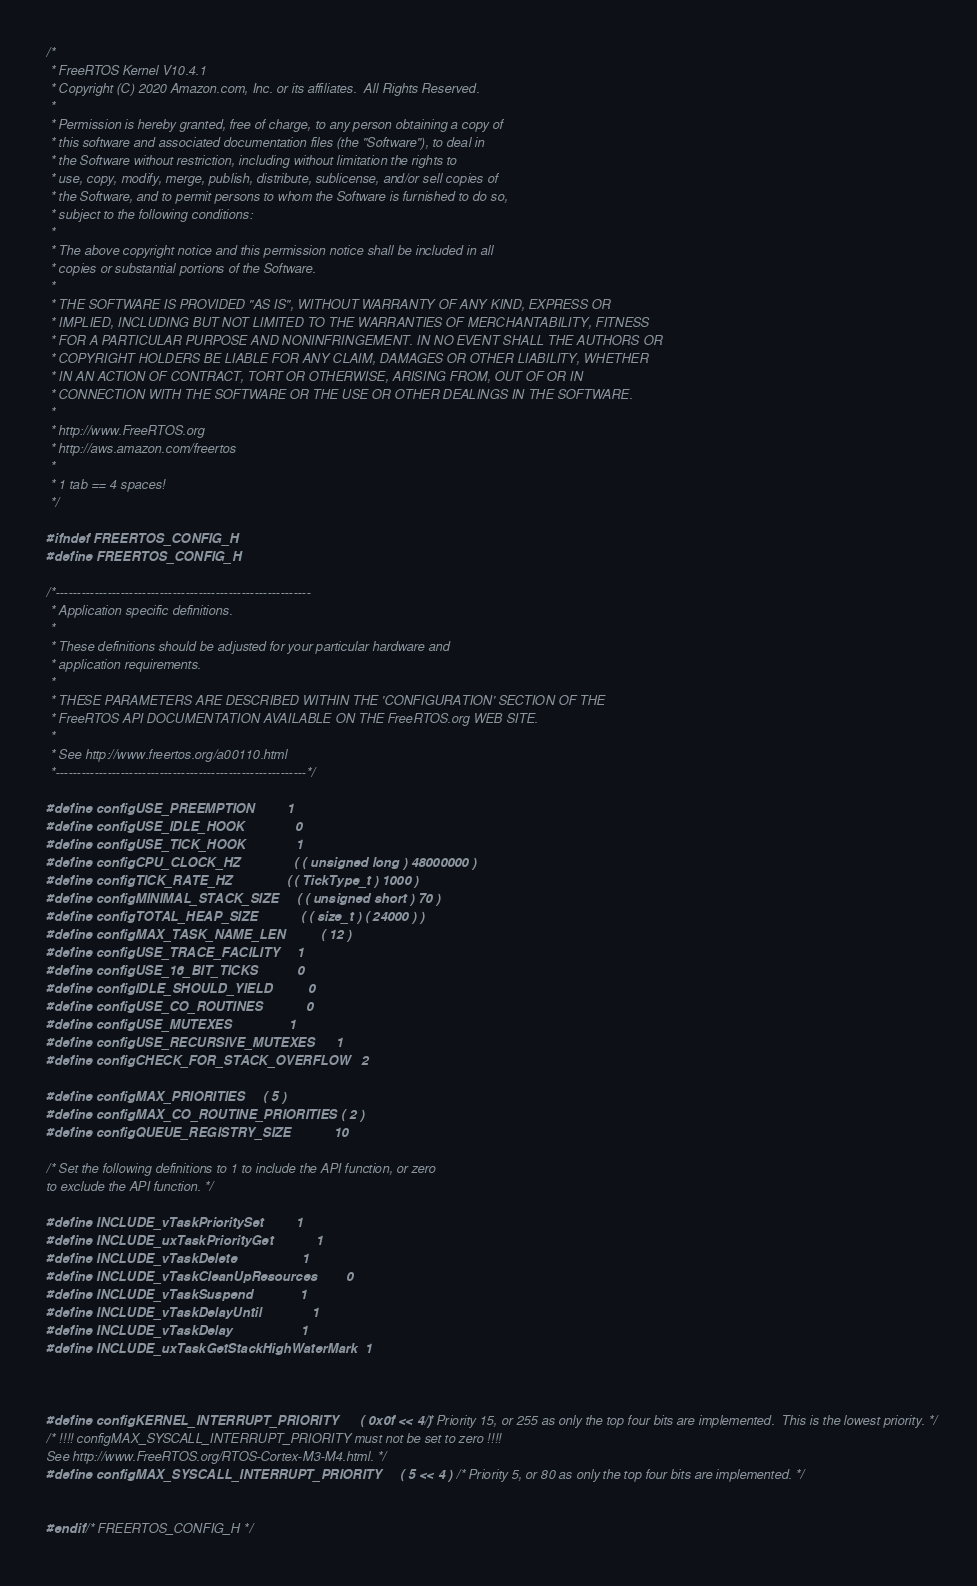<code> <loc_0><loc_0><loc_500><loc_500><_C_>/*
 * FreeRTOS Kernel V10.4.1
 * Copyright (C) 2020 Amazon.com, Inc. or its affiliates.  All Rights Reserved.
 *
 * Permission is hereby granted, free of charge, to any person obtaining a copy of
 * this software and associated documentation files (the "Software"), to deal in
 * the Software without restriction, including without limitation the rights to
 * use, copy, modify, merge, publish, distribute, sublicense, and/or sell copies of
 * the Software, and to permit persons to whom the Software is furnished to do so,
 * subject to the following conditions:
 *
 * The above copyright notice and this permission notice shall be included in all
 * copies or substantial portions of the Software.
 *
 * THE SOFTWARE IS PROVIDED "AS IS", WITHOUT WARRANTY OF ANY KIND, EXPRESS OR
 * IMPLIED, INCLUDING BUT NOT LIMITED TO THE WARRANTIES OF MERCHANTABILITY, FITNESS
 * FOR A PARTICULAR PURPOSE AND NONINFRINGEMENT. IN NO EVENT SHALL THE AUTHORS OR
 * COPYRIGHT HOLDERS BE LIABLE FOR ANY CLAIM, DAMAGES OR OTHER LIABILITY, WHETHER
 * IN AN ACTION OF CONTRACT, TORT OR OTHERWISE, ARISING FROM, OUT OF OR IN
 * CONNECTION WITH THE SOFTWARE OR THE USE OR OTHER DEALINGS IN THE SOFTWARE.
 *
 * http://www.FreeRTOS.org
 * http://aws.amazon.com/freertos
 *
 * 1 tab == 4 spaces!
 */

#ifndef FREERTOS_CONFIG_H
#define FREERTOS_CONFIG_H

/*-----------------------------------------------------------
 * Application specific definitions.
 *
 * These definitions should be adjusted for your particular hardware and
 * application requirements.
 *
 * THESE PARAMETERS ARE DESCRIBED WITHIN THE 'CONFIGURATION' SECTION OF THE
 * FreeRTOS API DOCUMENTATION AVAILABLE ON THE FreeRTOS.org WEB SITE.
 *
 * See http://www.freertos.org/a00110.html
 *----------------------------------------------------------*/

#define configUSE_PREEMPTION			1
#define configUSE_IDLE_HOOK				0
#define configUSE_TICK_HOOK				1
#define configCPU_CLOCK_HZ				( ( unsigned long ) 48000000 )
#define configTICK_RATE_HZ				( ( TickType_t ) 1000 )
#define configMINIMAL_STACK_SIZE		( ( unsigned short ) 70 )
#define configTOTAL_HEAP_SIZE			( ( size_t ) ( 24000 ) )
#define configMAX_TASK_NAME_LEN			( 12 )
#define configUSE_TRACE_FACILITY		1
#define configUSE_16_BIT_TICKS			0
#define configIDLE_SHOULD_YIELD			0
#define configUSE_CO_ROUTINES 			0
#define configUSE_MUTEXES				1
#define configUSE_RECURSIVE_MUTEXES		1
#define configCHECK_FOR_STACK_OVERFLOW	2

#define configMAX_PRIORITIES		( 5 )
#define configMAX_CO_ROUTINE_PRIORITIES ( 2 )
#define configQUEUE_REGISTRY_SIZE			10

/* Set the following definitions to 1 to include the API function, or zero
to exclude the API function. */

#define INCLUDE_vTaskPrioritySet			1
#define INCLUDE_uxTaskPriorityGet			1
#define INCLUDE_vTaskDelete					1
#define INCLUDE_vTaskCleanUpResources		0
#define INCLUDE_vTaskSuspend				1
#define INCLUDE_vTaskDelayUntil				1
#define INCLUDE_vTaskDelay					1
#define INCLUDE_uxTaskGetStackHighWaterMark	1



#define configKERNEL_INTERRUPT_PRIORITY 		( 0x0f << 4 )	/* Priority 15, or 255 as only the top four bits are implemented.  This is the lowest priority. */
/* !!!! configMAX_SYSCALL_INTERRUPT_PRIORITY must not be set to zero !!!!
See http://www.FreeRTOS.org/RTOS-Cortex-M3-M4.html. */
#define configMAX_SYSCALL_INTERRUPT_PRIORITY 	( 5 << 4 )  	/* Priority 5, or 80 as only the top four bits are implemented. */


#endif /* FREERTOS_CONFIG_H */
</code> 